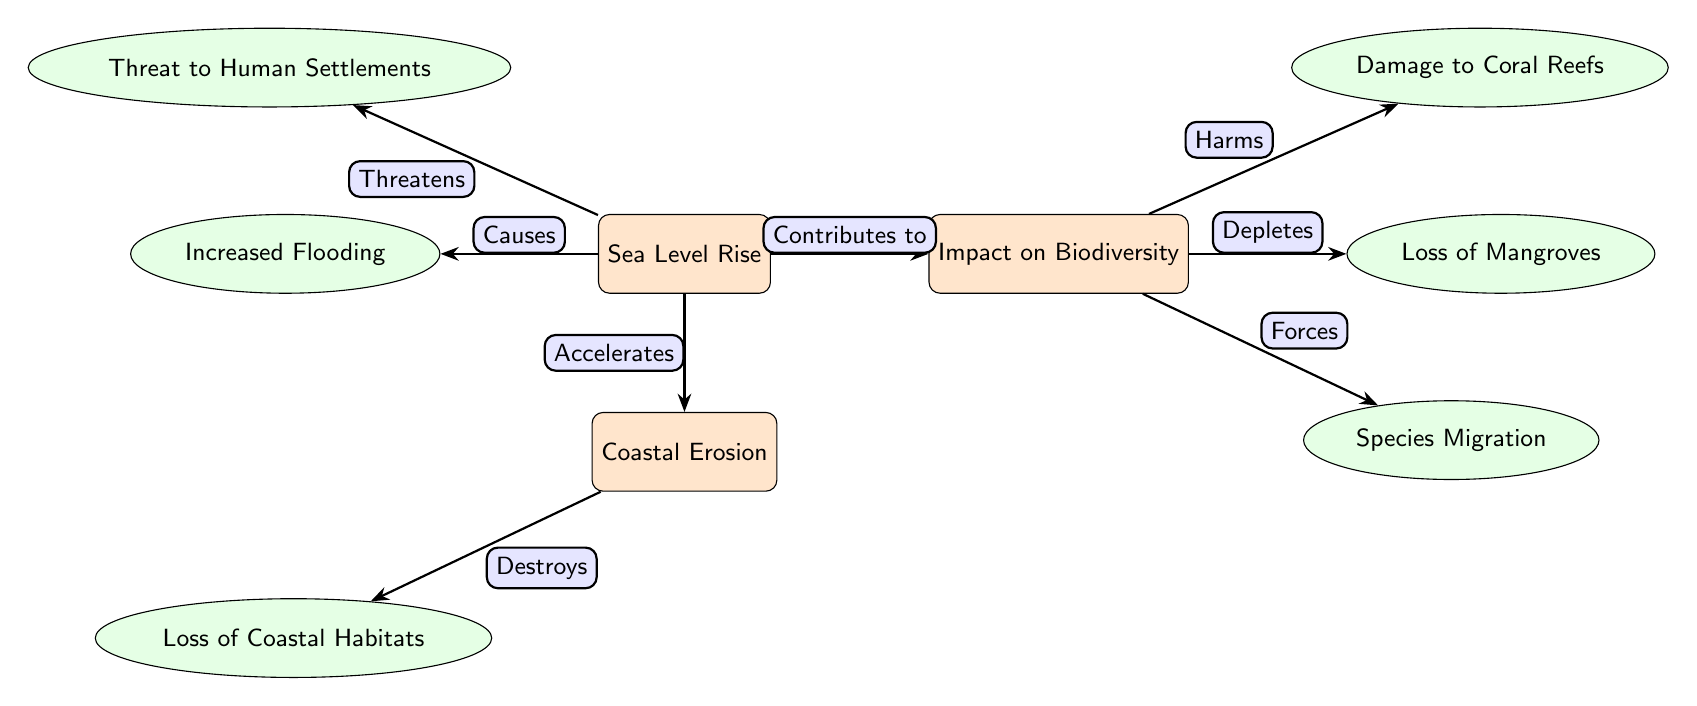What are the main impacts of sea level rise? The diagram shows that the main impacts of sea level rise include increased flooding, threats to human settlements, and contributions to biodiversity loss.
Answer: Increased flooding, threats to human settlements, contributions to biodiversity loss How many main nodes are in the diagram? The diagram has three main nodes: Sea Level Rise, Coastal Erosion, and Impact on Biodiversity. Counting these gives a total of three.
Answer: 3 Which secondary node is linked to coastal erosion? The secondary node linked to coastal erosion is "Loss of Coastal Habitats." A path labeled "Destroys" connects them.
Answer: Loss of Coastal Habitats What effect does biodiversity loss have on species? Biodiversity loss forces species migration, as indicated by the arrow and label between these two nodes in the diagram.
Answer: Forces What relationship exists between sea level rise and flooding? The relationship is that sea level rise causes flooding, as shown by the arrow labeled "Causes" connecting the Sea Level Rise node to the Flooding node.
Answer: Causes What happens to coral reefs as a result of biodiversity loss? The diagram indicates that biodiversity loss harms coral reefs, as depicted by the labeled arrow connecting these two nodes.
Answer: Harms How does coastal erosion relate to habitat loss? Coastal erosion destroys coastal habitats, as established by the arrow labeled "Destroys" connecting Coastal Erosion to the Loss of Coastal Habitats node.
Answer: Destroys What is the impact of sea level rise on human settlements? The impact of sea level rise on human settlements is that it threatens them, evidenced by the "Threatens" label connecting the two nodes in the diagram.
Answer: Threatens 